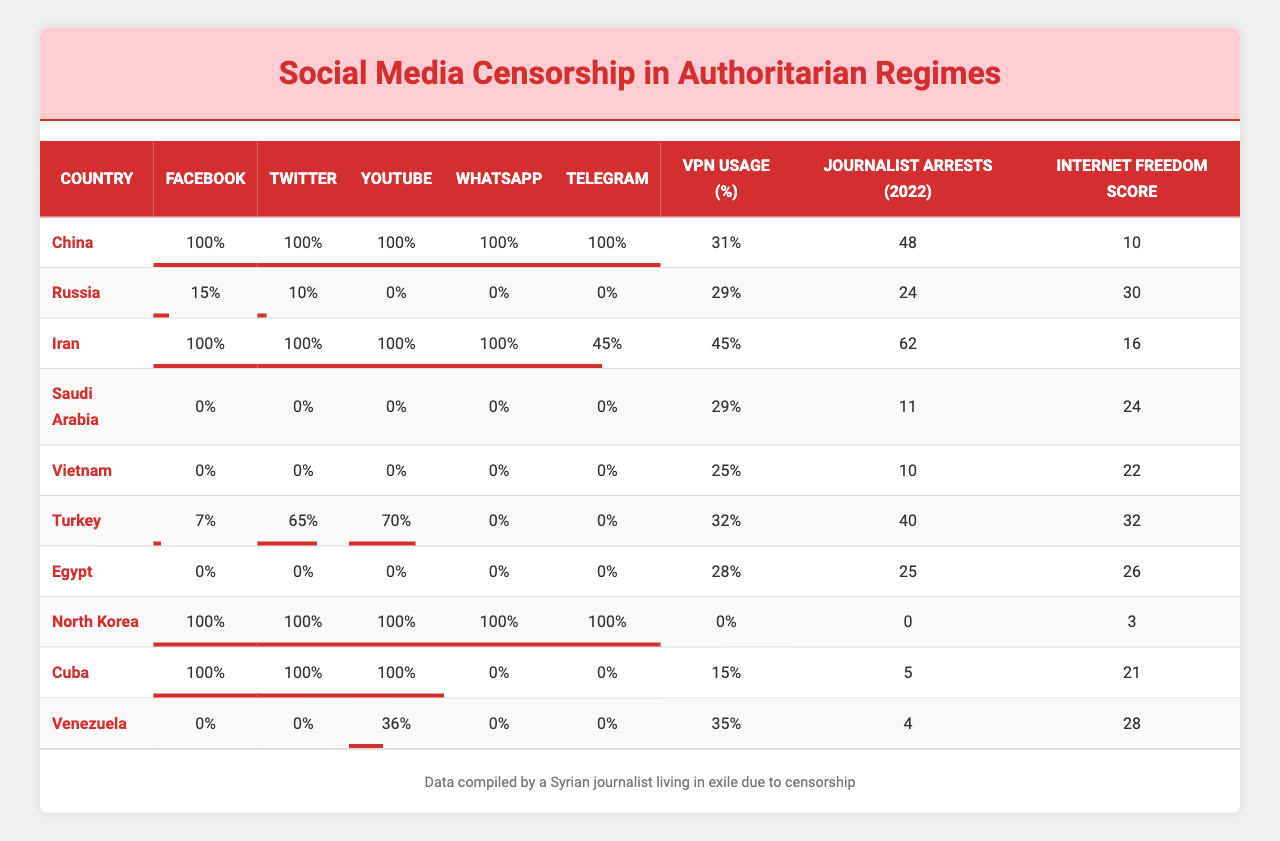What is the censorship rate for Facebook in China? The table shows that the Facebook censorship rate for China is 100%.
Answer: 100% Which country has the highest Twitter censorship rate? From the table, both China and Iran have a Twitter censorship rate of 100%, which is the highest among the listed countries.
Answer: China and Iran What is the WhatsApp censorship rate in Turkey? According to the table, Turkey has a WhatsApp censorship rate of 0%.
Answer: 0% Which country has the lowest Internet Freedom Score? The table indicates that North Korea has the lowest Internet Freedom Score at 3.
Answer: 3 How many journalist arrests were reported in Egypt in 2022? The table shows that there were 25 journalist arrests reported in Egypt in 2022.
Answer: 25 What is the average Facebook censorship rate of the countries listed? To calculate the average, sum the rates (100 + 15 + 100 + 0 + 0 + 7 + 0 + 100 + 100 + 0 = 422) and divide by 10, resulting in an average of 42.2%.
Answer: 42.2% Is the censorship rate for YouTube in Russia greater than that in Saudi Arabia? The table shows that Russia has a YouTube censorship rate of 0%, while Saudi Arabia has a 0% as well, making them equal, not greater.
Answer: No Which country has the highest percentage of VPN usage? The table reveals that Syria has the highest VPN usage percentage at 35%.
Answer: 35% What’s the total number of journalist arrests in China and Iran combined? By adding the journalist arrests from China (48) and Iran (62), we find that the total is 110 (48 + 62 = 110).
Answer: 110 Is it true that Vietnam has a WhatsApp censorship rate of 0%? As per the table, Vietnam's WhatsApp censorship rate is indeed 0%, confirming the statement as true.
Answer: Yes What is the difference between the YouTube censorship rates in Vietnam and Venezuela? Vietnam has a YouTube censorship rate of 0%, while Venezuela has a rate of 36%. The difference is calculated as 36 - 0 = 36.
Answer: 36 